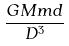<formula> <loc_0><loc_0><loc_500><loc_500>\frac { G M m d } { D ^ { 3 } }</formula> 